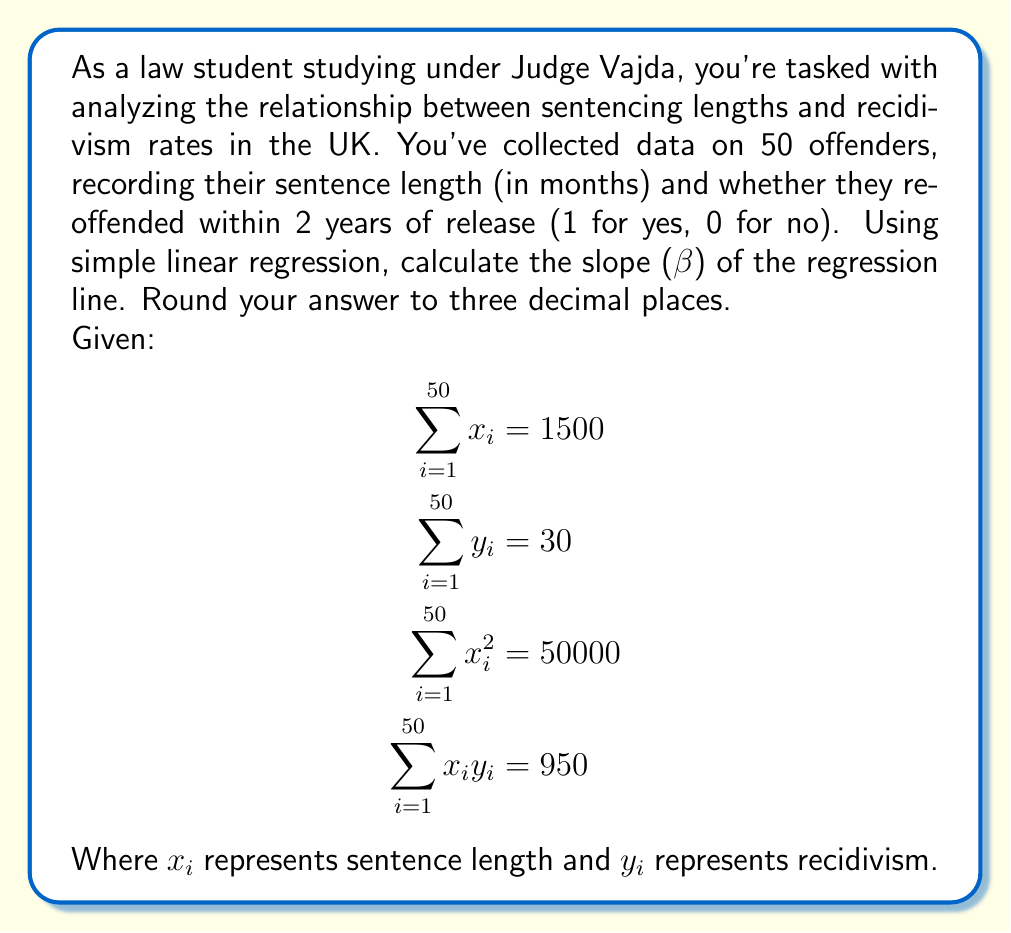What is the answer to this math problem? To calculate the slope (β) of the regression line, we'll use the formula:

$$\beta = \frac{n\sum x_iy_i - \sum x_i\sum y_i}{n\sum x_i^2 - (\sum x_i)^2}$$

Where n is the number of data points (50 in this case).

Step 1: Substitute the given values into the formula
$$\beta = \frac{50(950) - (1500)(30)}{50(50000) - (1500)^2}$$

Step 2: Calculate the numerator
$$50(950) = 47500$$
$$(1500)(30) = 45000$$
$$47500 - 45000 = 2500$$

Step 3: Calculate the denominator
$$50(50000) = 2500000$$
$$(1500)^2 = 2250000$$
$$2500000 - 2250000 = 250000$$

Step 4: Divide the numerator by the denominator
$$\beta = \frac{2500}{250000} = 0.01$$

Step 5: Round to three decimal places
$$\beta = 0.010$$
Answer: 0.010 